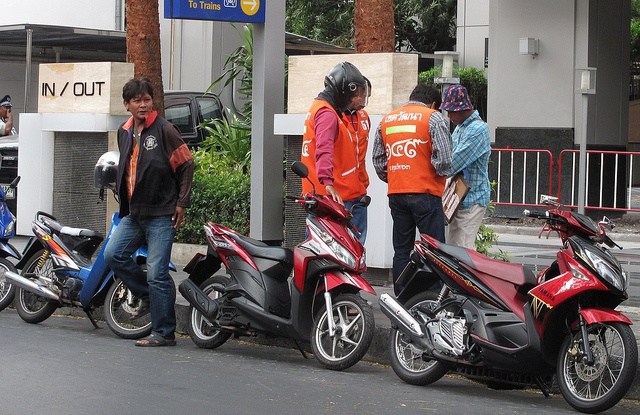Describe the objects in this image and their specific colors. I can see motorcycle in white, black, gray, darkgray, and lightgray tones, motorcycle in white, black, gray, darkgray, and lightgray tones, people in white, black, gray, navy, and maroon tones, motorcycle in white, black, gray, darkgray, and lightgray tones, and people in white, black, red, lightgray, and gray tones in this image. 